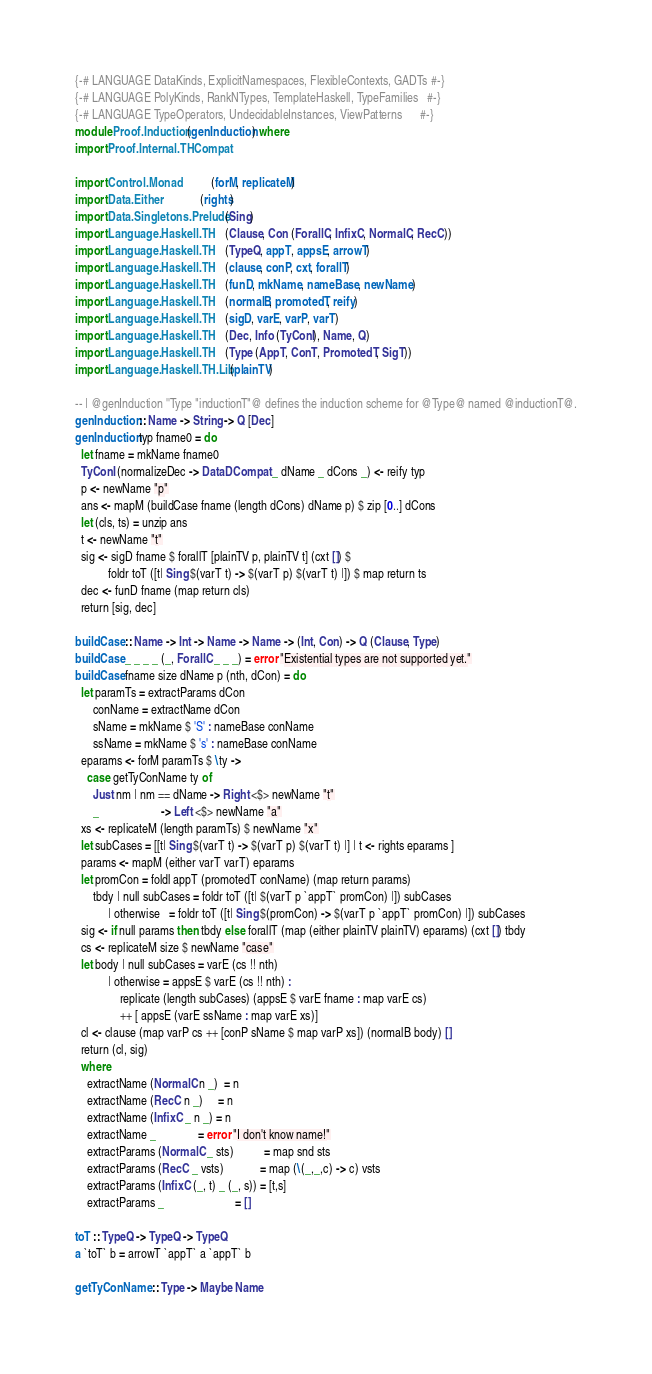<code> <loc_0><loc_0><loc_500><loc_500><_Haskell_>{-# LANGUAGE DataKinds, ExplicitNamespaces, FlexibleContexts, GADTs #-}
{-# LANGUAGE PolyKinds, RankNTypes, TemplateHaskell, TypeFamilies   #-}
{-# LANGUAGE TypeOperators, UndecidableInstances, ViewPatterns      #-}
module Proof.Induction (genInduction) where
import Proof.Internal.THCompat

import Control.Monad           (forM, replicateM)
import Data.Either             (rights)
import Data.Singletons.Prelude (Sing)
import Language.Haskell.TH     (Clause, Con (ForallC, InfixC, NormalC, RecC))
import Language.Haskell.TH     (TypeQ, appT, appsE, arrowT)
import Language.Haskell.TH     (clause, conP, cxt, forallT)
import Language.Haskell.TH     (funD, mkName, nameBase, newName)
import Language.Haskell.TH     (normalB, promotedT, reify)
import Language.Haskell.TH     (sigD, varE, varP, varT)
import Language.Haskell.TH     (Dec, Info (TyConI), Name, Q)
import Language.Haskell.TH     (Type (AppT, ConT, PromotedT, SigT))
import Language.Haskell.TH.Lib (plainTV)

-- | @genInduction ''Type "inductionT"@ defines the induction scheme for @Type@ named @inductionT@.
genInduction :: Name -> String -> Q [Dec]
genInduction typ fname0 = do
  let fname = mkName fname0
  TyConI (normalizeDec -> DataDCompat _ dName _ dCons _) <- reify typ
  p <- newName "p"
  ans <- mapM (buildCase fname (length dCons) dName p) $ zip [0..] dCons
  let (cls, ts) = unzip ans
  t <- newName "t"
  sig <- sigD fname $ forallT [plainTV p, plainTV t] (cxt []) $
           foldr toT ([t| Sing $(varT t) -> $(varT p) $(varT t) |]) $ map return ts
  dec <- funD fname (map return cls)
  return [sig, dec]

buildCase :: Name -> Int -> Name -> Name -> (Int, Con) -> Q (Clause, Type)
buildCase _ _ _ _ (_, ForallC _ _ _) = error "Existential types are not supported yet."
buildCase fname size dName p (nth, dCon) = do
  let paramTs = extractParams dCon
      conName = extractName dCon
      sName = mkName $ 'S' : nameBase conName
      ssName = mkName $ 's' : nameBase conName
  eparams <- forM paramTs $ \ty ->
    case getTyConName ty of
      Just nm | nm == dName -> Right <$> newName "t"
      _                     -> Left <$> newName "a"
  xs <- replicateM (length paramTs) $ newName "x"
  let subCases = [[t| Sing $(varT t) -> $(varT p) $(varT t) |] | t <- rights eparams ]
  params <- mapM (either varT varT) eparams
  let promCon = foldl appT (promotedT conName) (map return params)
      tbdy | null subCases = foldr toT ([t| $(varT p `appT` promCon) |]) subCases
           | otherwise   = foldr toT ([t| Sing $(promCon) -> $(varT p `appT` promCon) |]) subCases
  sig <- if null params then tbdy else forallT (map (either plainTV plainTV) eparams) (cxt []) tbdy
  cs <- replicateM size $ newName "case"
  let body | null subCases = varE (cs !! nth)
           | otherwise = appsE $ varE (cs !! nth) :
               replicate (length subCases) (appsE $ varE fname : map varE cs)
               ++ [ appsE (varE ssName : map varE xs)]
  cl <- clause (map varP cs ++ [conP sName $ map varP xs]) (normalB body) []
  return (cl, sig)
  where
    extractName (NormalC n _)  = n
    extractName (RecC n _)     = n
    extractName (InfixC _ n _) = n
    extractName _              = error "I don't know name!"
    extractParams (NormalC _ sts)          = map snd sts
    extractParams (RecC _ vsts)            = map (\(_,_,c) -> c) vsts
    extractParams (InfixC (_, t) _ (_, s)) = [t,s]
    extractParams _                        = []

toT :: TypeQ -> TypeQ -> TypeQ
a `toT` b = arrowT `appT` a `appT` b

getTyConName :: Type -> Maybe Name</code> 